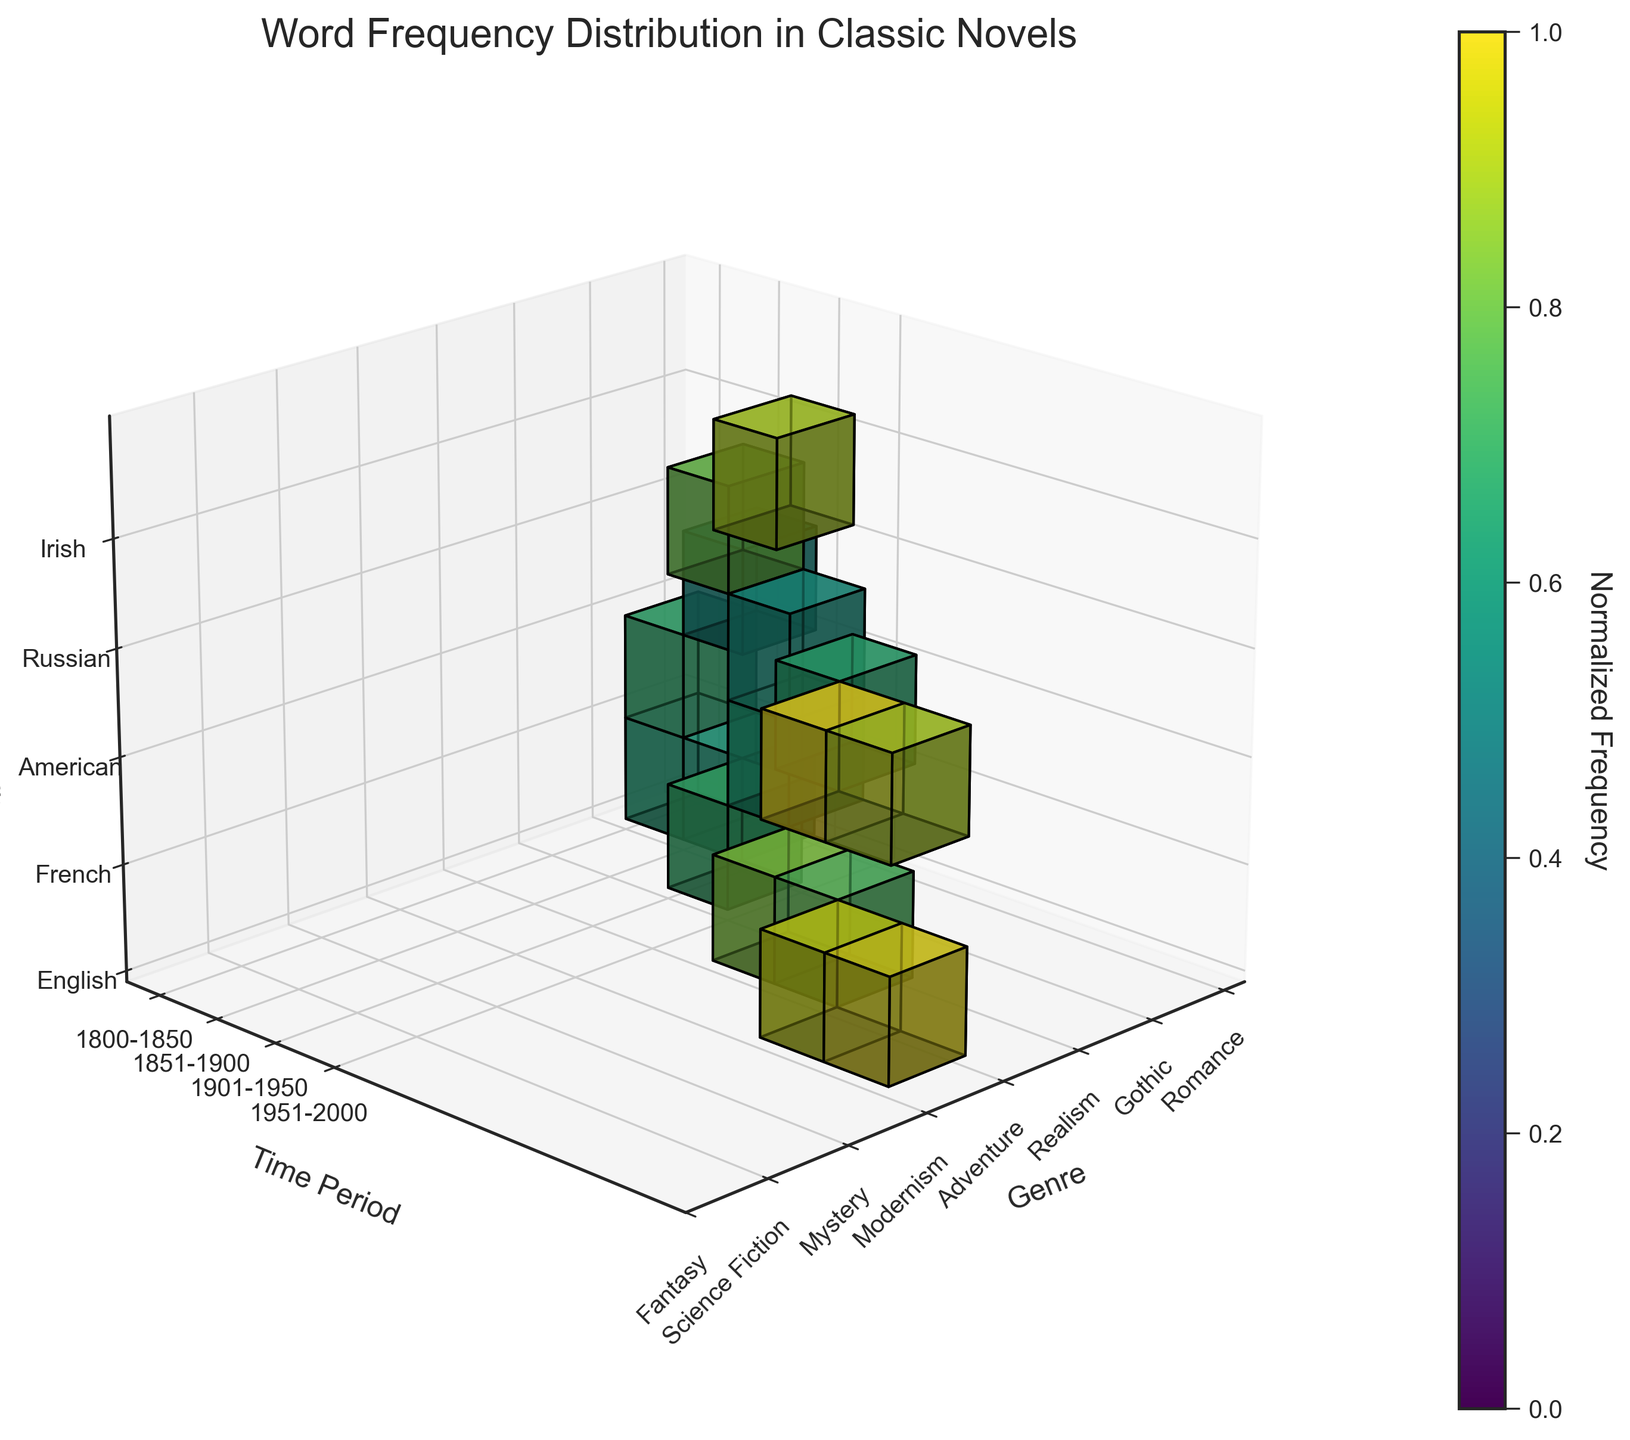What is the title of the plot? The title is displayed at the top of the figure, which reads "Word Frequency Distribution in Classic Novels".
Answer: Word Frequency Distribution in Classic Novels What do the colors in the voxels represent? The color of each voxel indicates the normalized frequency of word usage within the data, ranging from low (indicated by darker colors) to high (indicated by lighter colors) frequency.
Answer: Normalized word frequency In which time period does the 'stream' word appear most frequently? Look at the 3D grid and identify the voxel corresponding to the 'stream' word under the time period labels on the y-axis (1901-1950), genre labels on the x-axis (Modernism), and nationality labels on the z-axis (Irish). This voxel has a high frequency.
Answer: 1901-1950 Which genre shows the highest normalized frequency of words in the 1901-1950 time period? Check the y-axis for the 1901-1950 period, and then move across genres on the x-axis. Identify the genre with the brightest color voxel indicating the highest frequency.
Answer: Modernism Do American authors or English authors use 'love' less frequently in the Romance genre during the 1800-1850 time period? Locate the voxels corresponding to the 'love' word in the 1800-1850 period and Romance genre for both American and English nationalities. The voxel for American authors is absent, meaning it is not used at all, while the English authors have a high-frequency count.
Answer: American authors How does the frequency of 'consciousness' in Modernism genre (1901-1950) compare to 'magic' in Fantasy genre (1951-2000)? Compare the brightness of the voxel for 'consciousness' in the 1901-1950 time period, Modernism genre, and English nationality with the voxel for 'magic' in the 1951-2000 time period, Fantasy genre, and English nationality. Both are fairly high, but 'magic' appears to have a slightly higher intensity.
Answer: Magic in Fantasy (1951-2000) is higher Which nationality has the highest frequency of word usage in the Science Fiction genre in the 1951-2000 period? Check the 1951-2000 time period on the y-axis, then locate the Science Fiction genre on the x-axis and compare the brightness of the voxels related to different nationalities on the z-axis. The voxel for American authors has a brighter color than others.
Answer: American What is the highest normalized frequency observed in the Realism genre during the 1851-1900 period? Check the 1851-1900 time period on the y-axis, locate the Realism genre on the x-axis, and identify which voxel (associated with which nationality) shows the highest normalized frequency based on its color intensity. The voxel for Russian authors has the brightest color.
Answer: Russian 